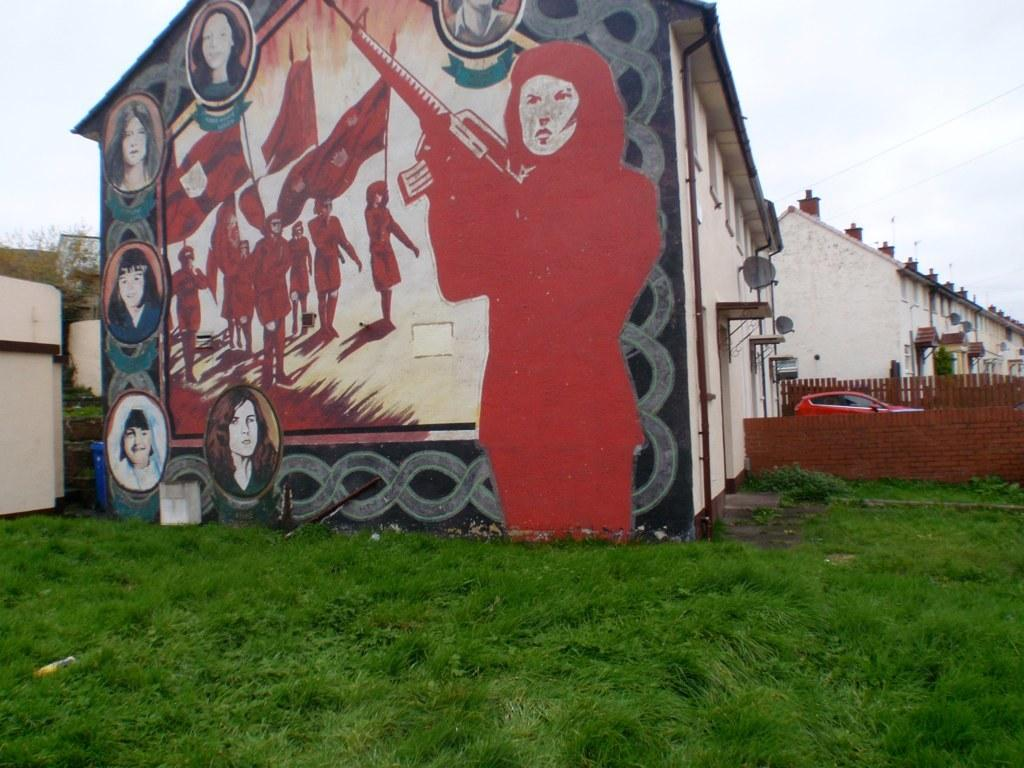What type of structure is present in the image? There is a building in the image. What can be seen on the wall of the building? There is a painting on the wall of the building. What other objects or features are visible in the image? There is a pipe, a fence, grass, a plant, and a red vehicle in the image. What part of the natural environment is visible in the image? Grass and the sky are visible in the image. Where is the stamp located in the image? There is no stamp present in the image. What type of muscle is being exercised by the plant in the image? Plants do not have muscles, so this question is not applicable to the image. 